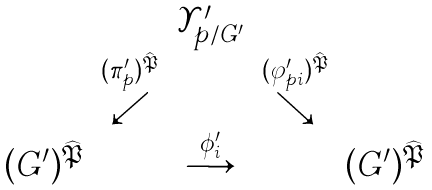<formula> <loc_0><loc_0><loc_500><loc_500>\begin{array} { c c c c c } \ & \ & { \mathcal { Y } } ^ { \prime } _ { p / G ^ { \prime } } & \ & \ \\ \ & \stackrel { ( \pi ^ { \prime } _ { p } ) ^ { \widehat { \mathfrak P } } } { \swarrow } & \ & \stackrel { ( \varphi ^ { \prime } _ { p i } ) ^ { \widehat { \mathfrak P } } } { \searrow } & \ \\ ( G ^ { \prime } ) ^ { \widehat { \mathfrak P } } & \ & \stackrel { \phi ^ { \prime } _ { i } } { \longrightarrow } & \ & ( G ^ { \prime } ) ^ { \widehat { \mathfrak P } } \end{array}</formula> 